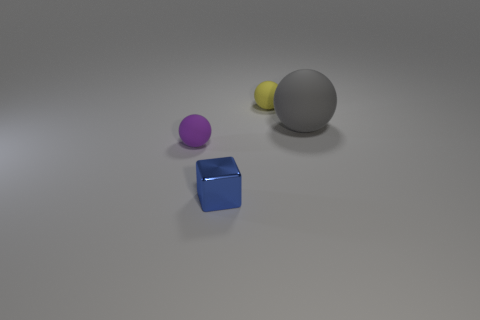What could be the context or purpose of these objects given their arrangement? The arrangement appears to be a simple still life composition, possibly for the purpose of a visual study or a 3D rendering demonstration. The varied sizes and colors, along with their spacing, suggest an exercise in perspective, shading, and color contrast. 